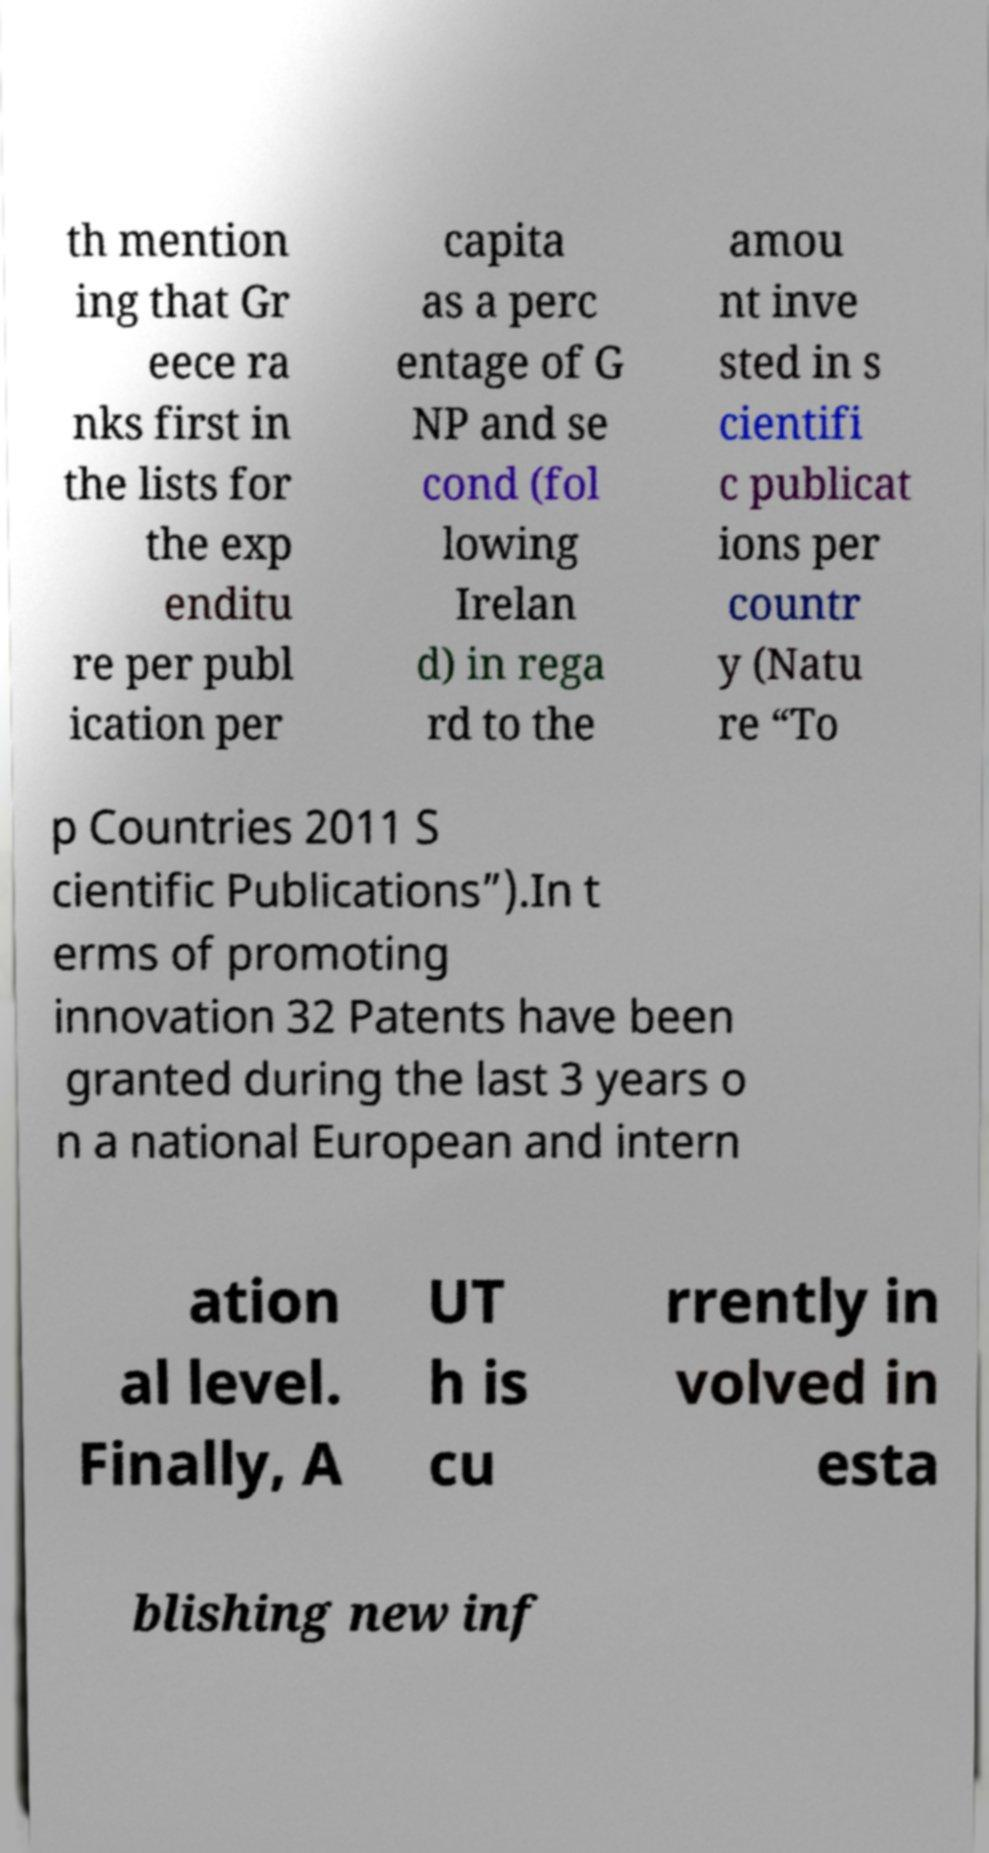Can you accurately transcribe the text from the provided image for me? th mention ing that Gr eece ra nks first in the lists for the exp enditu re per publ ication per capita as a perc entage of G NP and se cond (fol lowing Irelan d) in rega rd to the amou nt inve sted in s cientifi c publicat ions per countr y (Natu re “To p Countries 2011 S cientific Publications”).In t erms of promoting innovation 32 Patents have been granted during the last 3 years o n a national European and intern ation al level. Finally, A UT h is cu rrently in volved in esta blishing new inf 